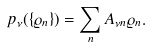<formula> <loc_0><loc_0><loc_500><loc_500>p _ { \nu } ( \{ \varrho _ { n } \} ) = \sum _ { n } A _ { \nu n } \varrho _ { n } .</formula> 